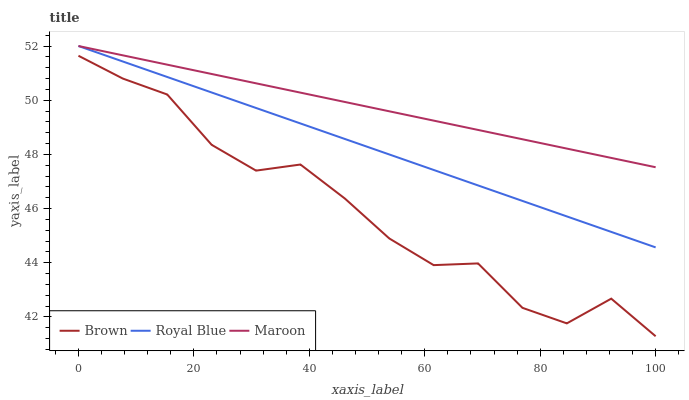Does Brown have the minimum area under the curve?
Answer yes or no. Yes. Does Maroon have the maximum area under the curve?
Answer yes or no. Yes. Does Royal Blue have the minimum area under the curve?
Answer yes or no. No. Does Royal Blue have the maximum area under the curve?
Answer yes or no. No. Is Maroon the smoothest?
Answer yes or no. Yes. Is Brown the roughest?
Answer yes or no. Yes. Is Royal Blue the smoothest?
Answer yes or no. No. Is Royal Blue the roughest?
Answer yes or no. No. Does Brown have the lowest value?
Answer yes or no. Yes. Does Royal Blue have the lowest value?
Answer yes or no. No. Does Royal Blue have the highest value?
Answer yes or no. Yes. Is Brown less than Maroon?
Answer yes or no. Yes. Is Royal Blue greater than Brown?
Answer yes or no. Yes. Does Royal Blue intersect Maroon?
Answer yes or no. Yes. Is Royal Blue less than Maroon?
Answer yes or no. No. Is Royal Blue greater than Maroon?
Answer yes or no. No. Does Brown intersect Maroon?
Answer yes or no. No. 